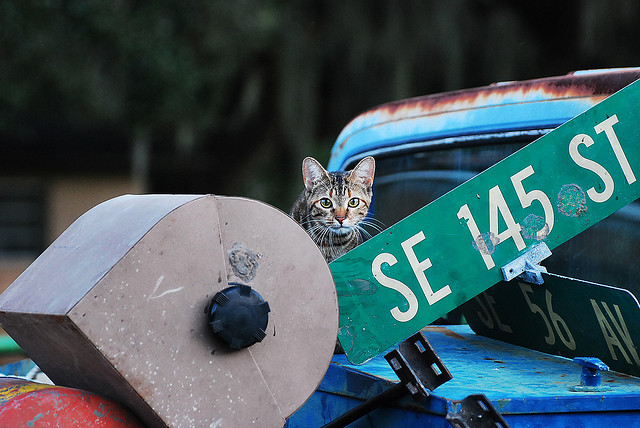Identify and read out the text in this image. SE 145 ST 56 AV SE 